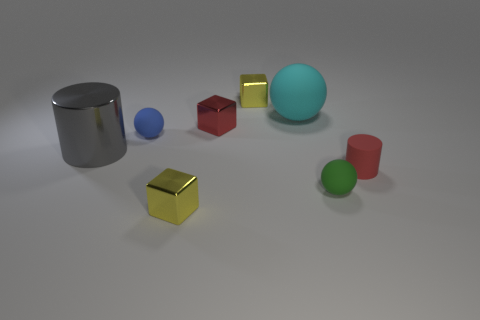Does the yellow metallic block behind the gray shiny object have the same size as the red thing that is to the left of the small green matte sphere?
Make the answer very short. Yes. Are there more green rubber spheres that are in front of the small red metal thing than small red rubber objects that are on the left side of the big gray thing?
Your response must be concise. Yes. How many other objects are the same color as the big metal cylinder?
Provide a short and direct response. 0. There is a tiny yellow thing that is in front of the gray shiny object; how many yellow objects are behind it?
Your answer should be compact. 1. There is a yellow block to the left of the tiny yellow thing that is behind the block in front of the small green rubber object; what is its material?
Give a very brief answer. Metal. There is a object that is on the right side of the big ball and to the left of the red rubber cylinder; what material is it?
Provide a succinct answer. Rubber. How many other big gray objects are the same shape as the large gray object?
Provide a succinct answer. 0. What size is the metal object that is left of the yellow shiny cube that is in front of the large gray cylinder?
Your answer should be very brief. Large. Is the color of the small metallic block that is in front of the red rubber thing the same as the tiny object that is behind the large cyan matte ball?
Your response must be concise. Yes. There is a small yellow object in front of the metal thing that is right of the tiny red shiny thing; how many tiny metal cubes are in front of it?
Offer a very short reply. 0. 